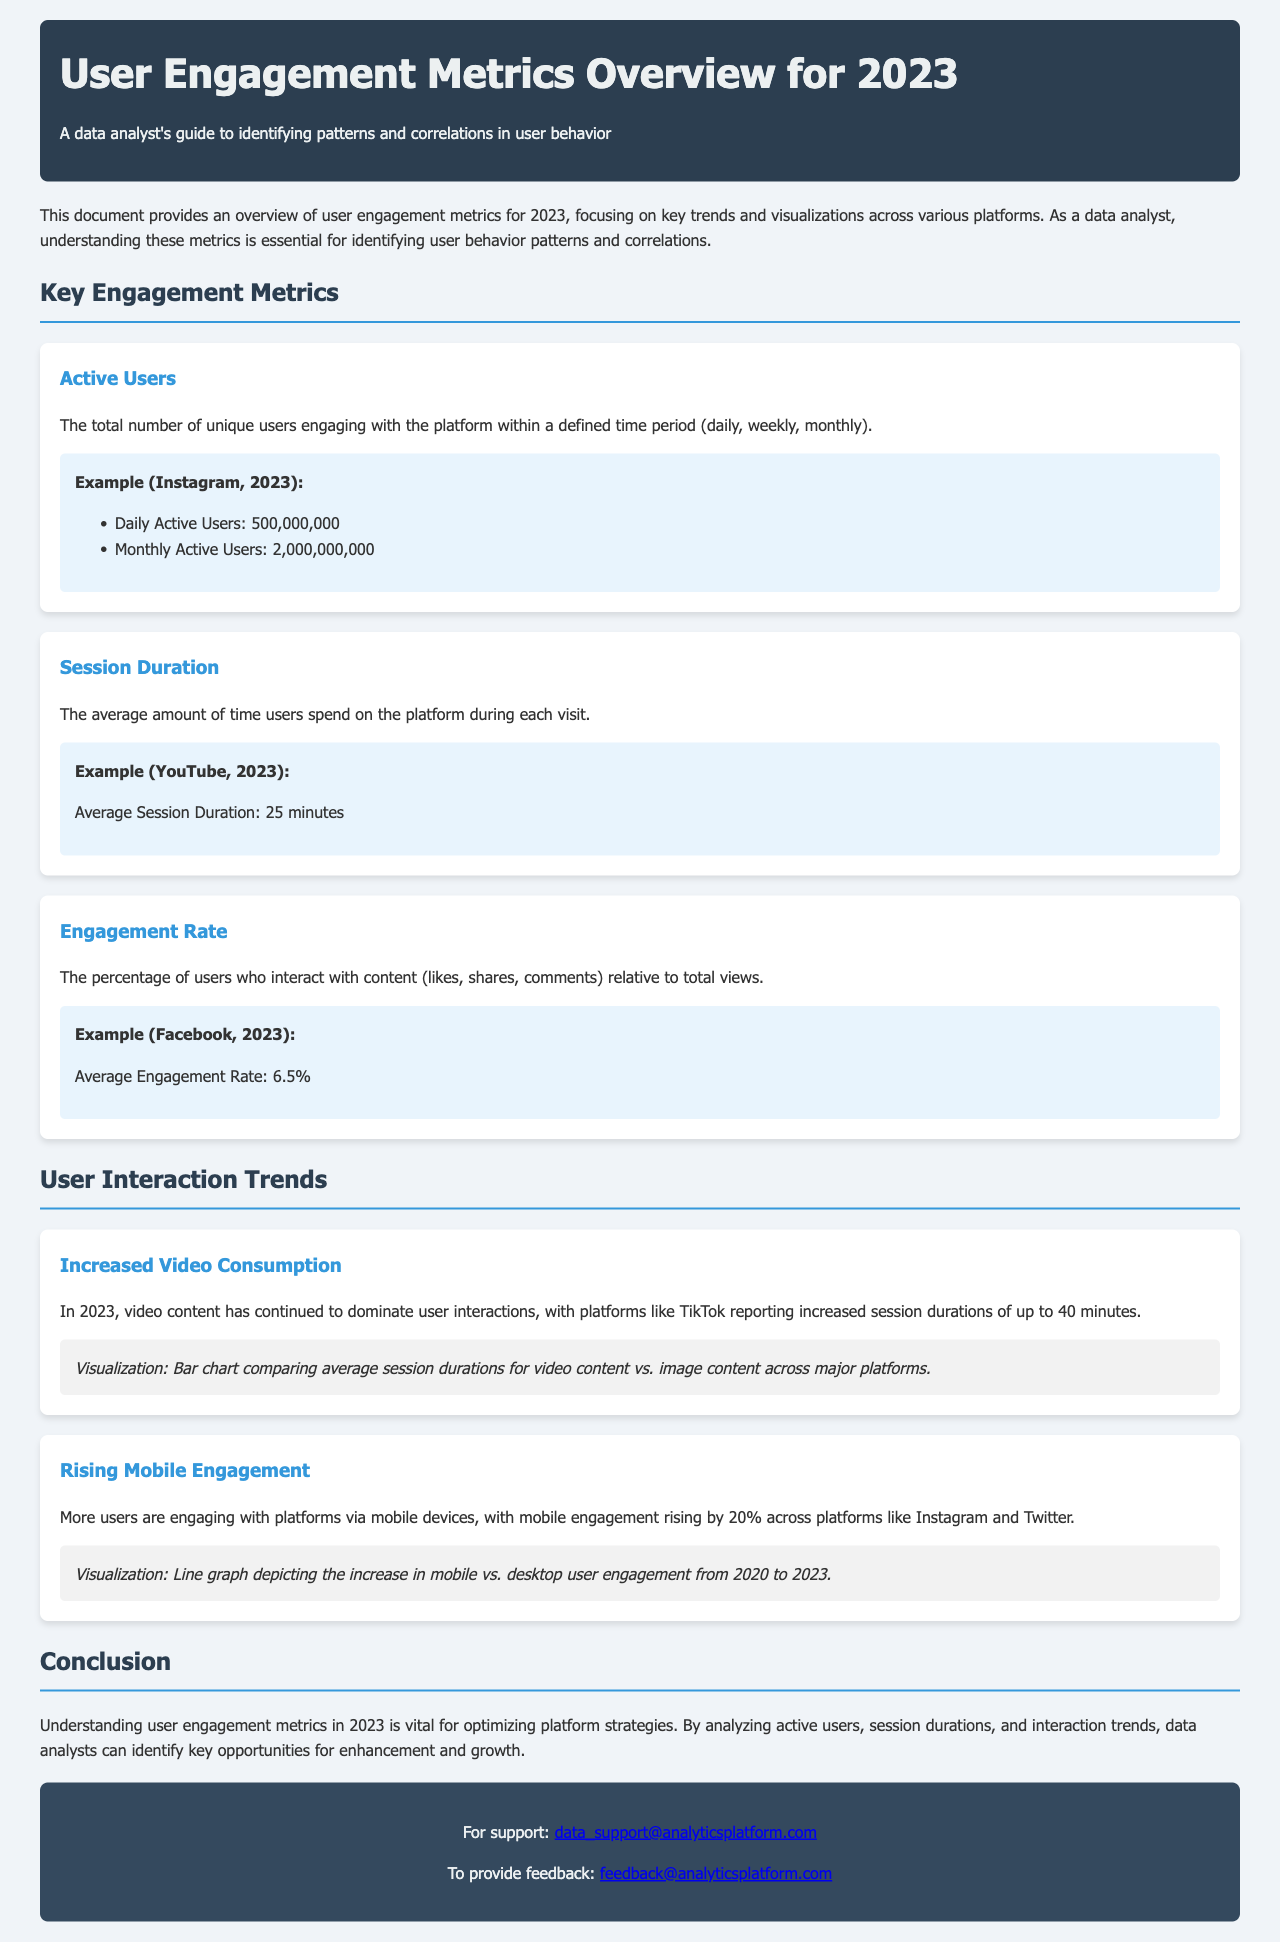What are the daily active users for Instagram in 2023? The document provides an example of Instagram's user engagement metrics, stating the Daily Active Users as 500,000,000.
Answer: 500,000,000 What is the average session duration for YouTube in 2023? The document contains an example indicating that the Average Session Duration for YouTube is 25 minutes.
Answer: 25 minutes What is the average engagement rate for Facebook in 2023? According to the document's example, the Average Engagement Rate for Facebook is 6.5%.
Answer: 6.5% What trend indicates increased user interaction with video content in 2023? The document cites an increase in video consumption, with platforms like TikTok reporting average session durations of up to 40 minutes.
Answer: Increased Video Consumption By what percentage did mobile engagement rise across platforms? The document notes that mobile engagement rose by 20% across platforms like Instagram and Twitter.
Answer: 20% Which type of visualization compares average session durations for video content vs. image content? The document specifies a bar chart as the visualization comparing average session durations for video content versus image content.
Answer: Bar chart What does the line graph visualize in the document? The line graph is described as depicting the increase in mobile vs. desktop user engagement from 2020 to 2023.
Answer: Increase in mobile vs. desktop user engagement What is the overall goal of understanding user engagement metrics in 2023, according to the document? The conclusion in the document emphasizes that understanding user engagement metrics is vital for optimizing platform strategies.
Answer: Optimizing platform strategies 